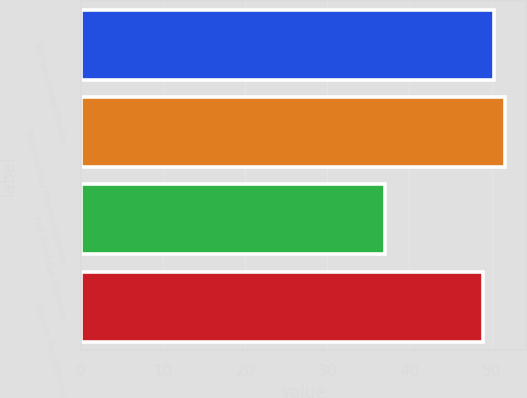Convert chart. <chart><loc_0><loc_0><loc_500><loc_500><bar_chart><fcel>Northern Border Pipeline<fcel>Overland Pass Pipeline Company<fcel>Fort Union Gas Gathering<fcel>Bighorn Gas Gathering<nl><fcel>50.3<fcel>51.6<fcel>37<fcel>49<nl></chart> 